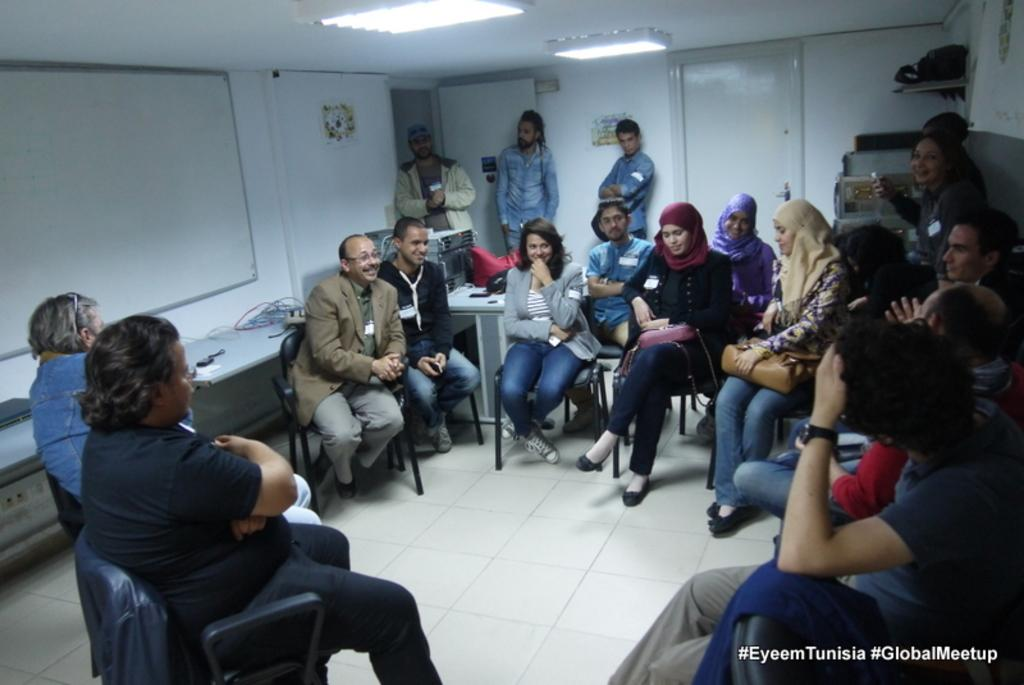What are the people in the image doing? The people in the image are sitting and talking. What can be seen in the background of the image? There is a board, a ceiling, and a light in the background of the image. How many people are standing in the image? Three people are standing in the image. Can you describe the appearance of one of the men? One man is wearing a cap. What type of scale is being used by the achiever in the image? There is no scale or achiever present in the image. 